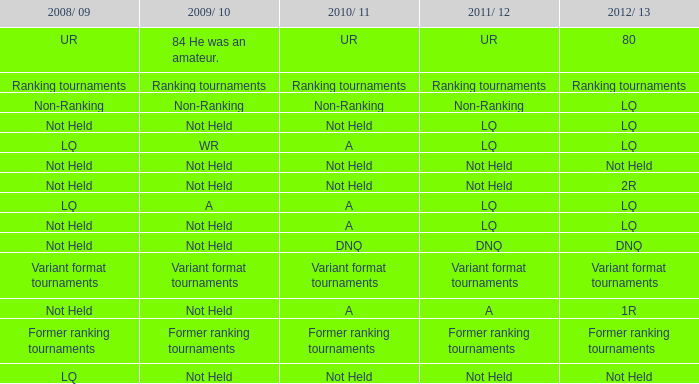When the 2008/09 season is not ranked, what is the 2009/10 season? Non-Ranking. 